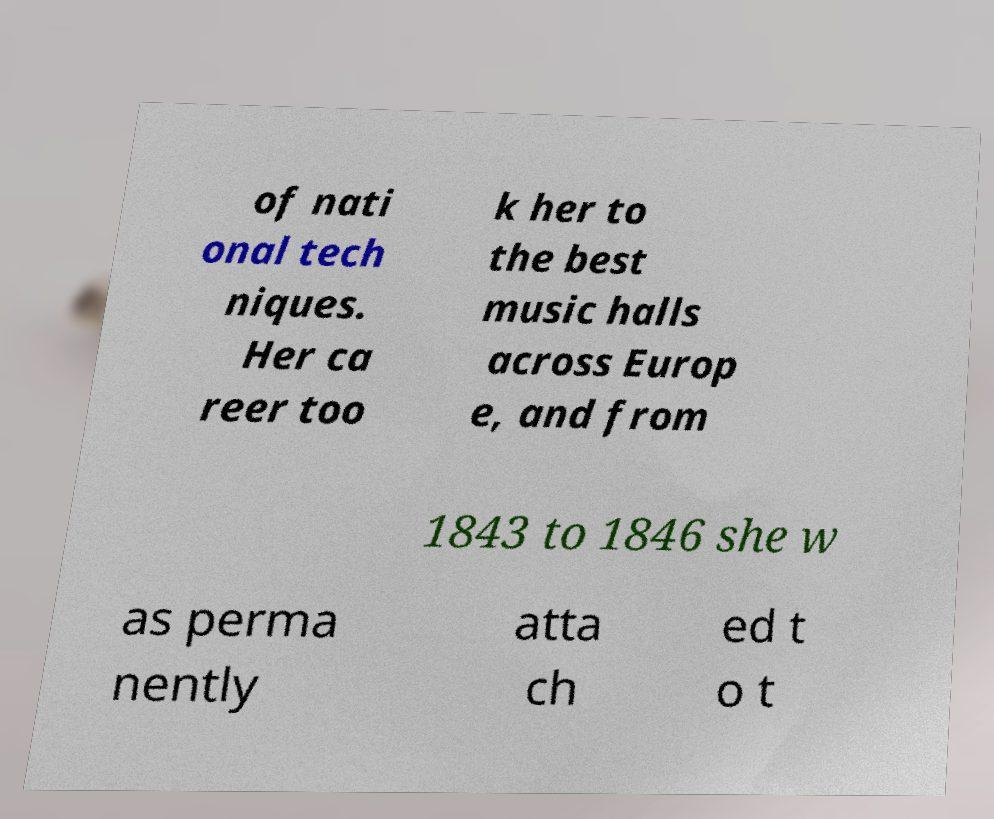Could you extract and type out the text from this image? of nati onal tech niques. Her ca reer too k her to the best music halls across Europ e, and from 1843 to 1846 she w as perma nently atta ch ed t o t 